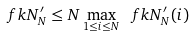<formula> <loc_0><loc_0><loc_500><loc_500>\ f k N _ { N } ^ { \prime } \leq N \max _ { 1 \leq i \leq N } \ f k N _ { N } ^ { \prime } ( i )</formula> 